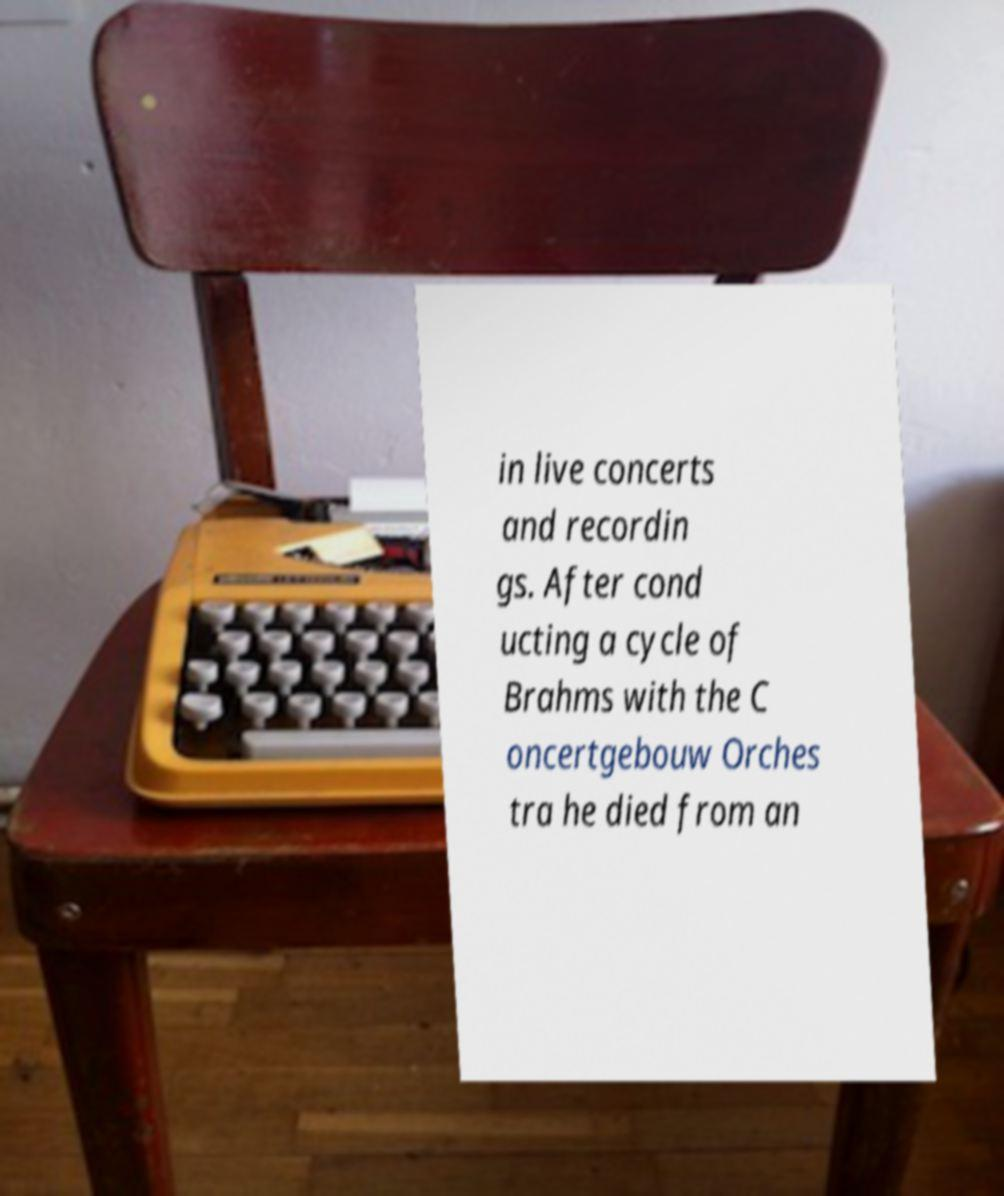Please identify and transcribe the text found in this image. in live concerts and recordin gs. After cond ucting a cycle of Brahms with the C oncertgebouw Orches tra he died from an 